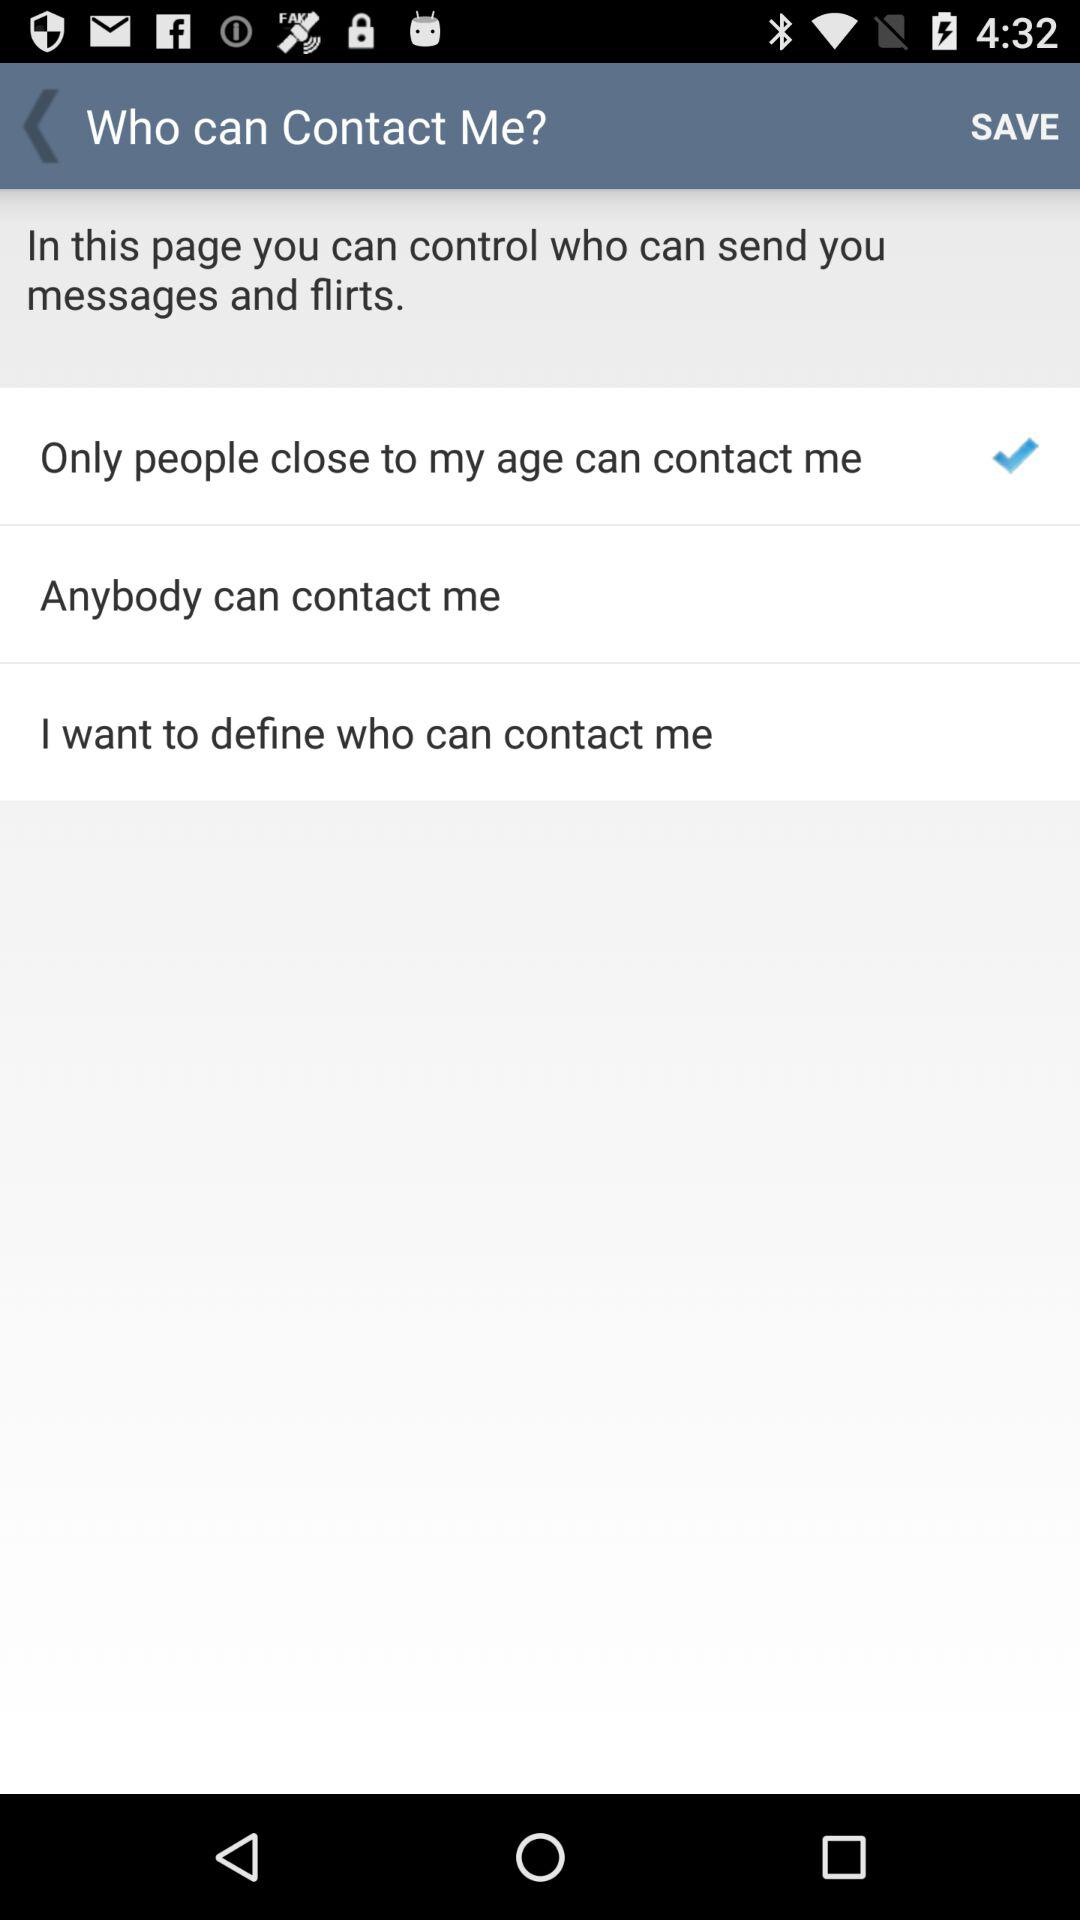How many messages does the user have?
When the provided information is insufficient, respond with <no answer>. <no answer> 